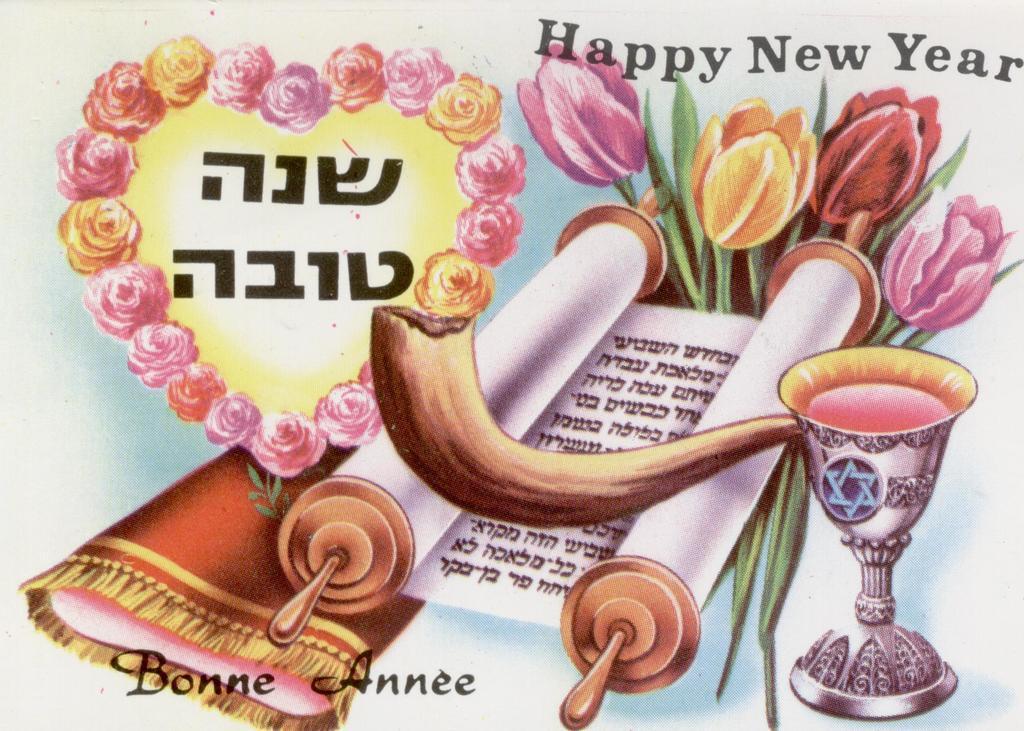Describe this image in one or two sentences. In this image I can see a depiction picture where I can see a cup, number of flowers, a paper roll and a red colour thing. On the top right corner and on the bottom left side of this image I can see something is written. 